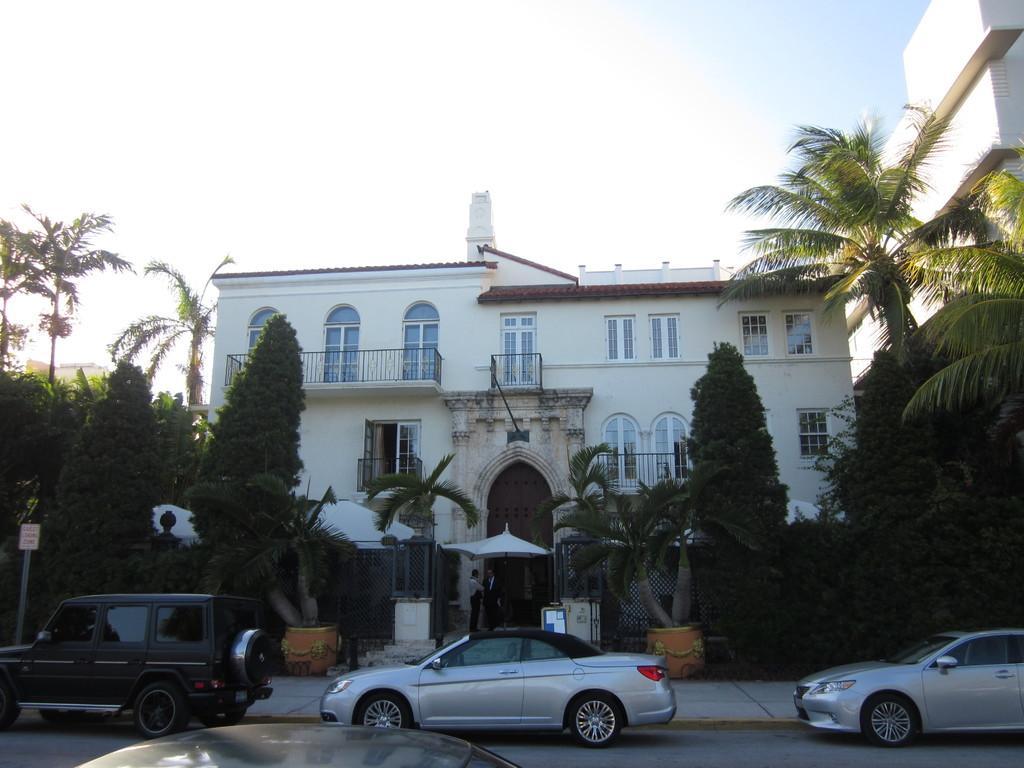Could you give a brief overview of what you see in this image? In the image there are few vehicles kept on the road and behind the road there is a building, there are two people standing in front of the door and around the building there are a lot of trees. 